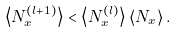Convert formula to latex. <formula><loc_0><loc_0><loc_500><loc_500>\left \langle N _ { x } ^ { ( l + 1 ) } \right \rangle < \left \langle N _ { x } ^ { ( l ) } \right \rangle \left \langle N _ { x } \right \rangle .</formula> 